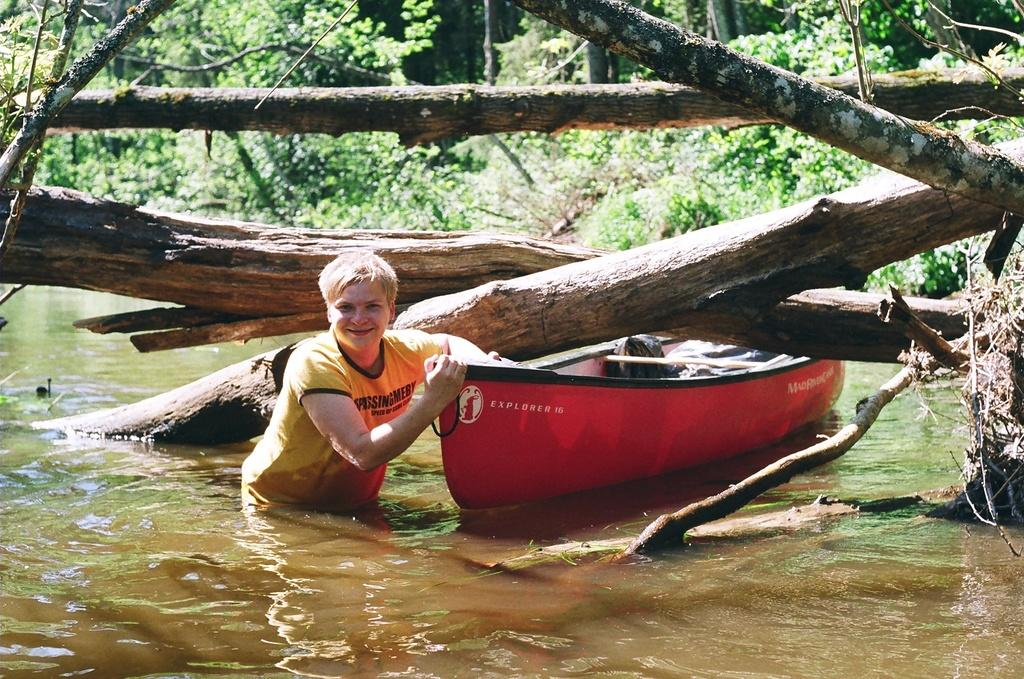What can be seen in the background of the image? There are trees and plants in the background of the image. What is the main subject of the image? There is a boat in the image. What is the setting of the image? There is water visible in the image. What else is present in the image besides the boat? There are branches and a person in the image. What is the person wearing? The person is wearing a t-shirt. What is the person doing with the boat? The person is holding a boat. What is the person's facial expression? The person is smiling. What type of lunchroom can be seen in the image? There is no lunchroom present in the image. How much salt is visible in the image? There is no salt present in the image. 